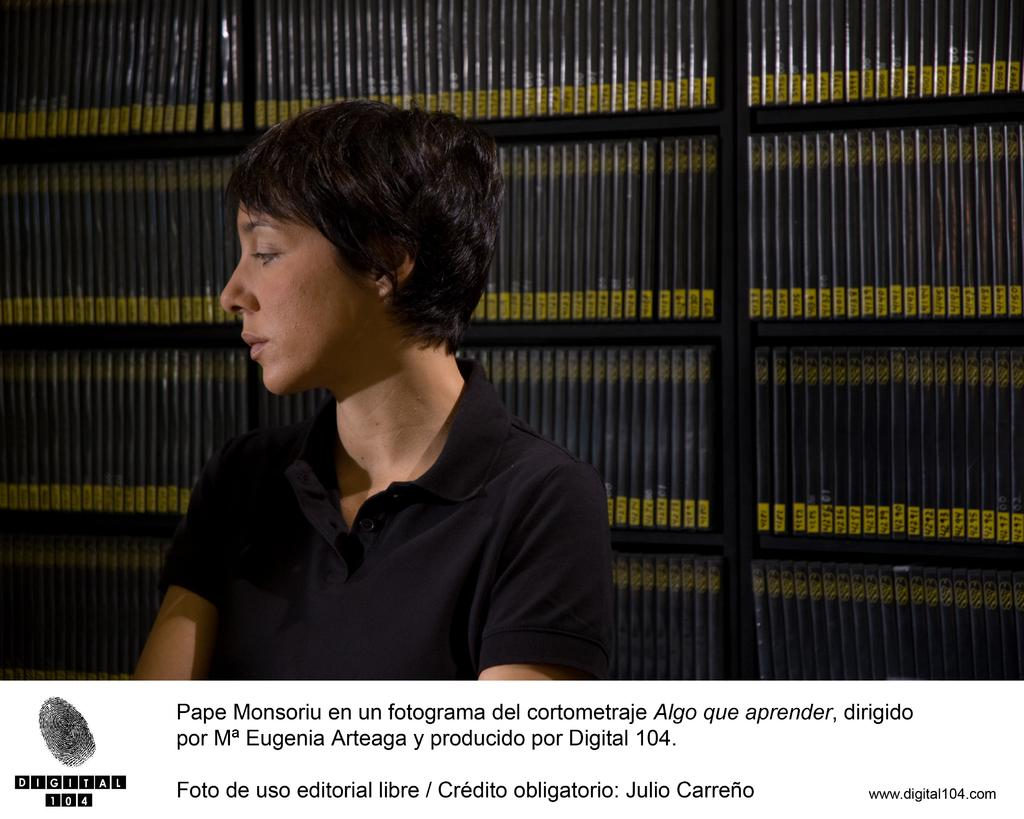What type of content is the image likely to be promoting? The image appears to be an advertisement. Can you read any text in the image? Yes, there is text at the bottom of the image. What is the primary subject in the foreground of the image? There is a person in the foreground of the image. What can be seen in the background of the image? There is a rack with books in the background of the image. What type of hook is being used to hold the books on the rack in the image? There is no hook visible in the image; the books are simply placed on the rack. 